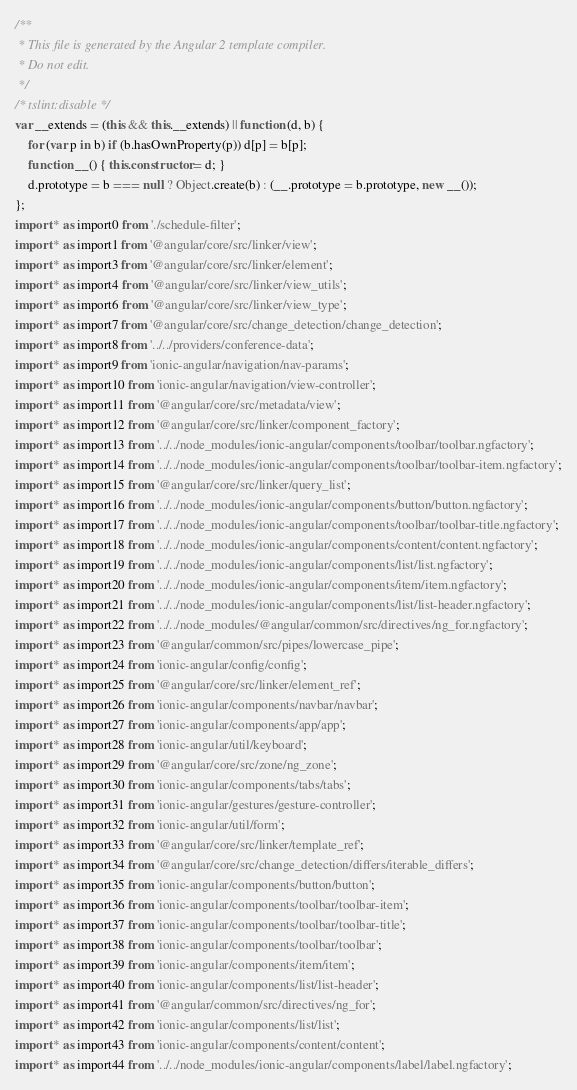<code> <loc_0><loc_0><loc_500><loc_500><_JavaScript_>/**
 * This file is generated by the Angular 2 template compiler.
 * Do not edit.
 */
/* tslint:disable */
var __extends = (this && this.__extends) || function (d, b) {
    for (var p in b) if (b.hasOwnProperty(p)) d[p] = b[p];
    function __() { this.constructor = d; }
    d.prototype = b === null ? Object.create(b) : (__.prototype = b.prototype, new __());
};
import * as import0 from './schedule-filter';
import * as import1 from '@angular/core/src/linker/view';
import * as import3 from '@angular/core/src/linker/element';
import * as import4 from '@angular/core/src/linker/view_utils';
import * as import6 from '@angular/core/src/linker/view_type';
import * as import7 from '@angular/core/src/change_detection/change_detection';
import * as import8 from '../../providers/conference-data';
import * as import9 from 'ionic-angular/navigation/nav-params';
import * as import10 from 'ionic-angular/navigation/view-controller';
import * as import11 from '@angular/core/src/metadata/view';
import * as import12 from '@angular/core/src/linker/component_factory';
import * as import13 from '../../node_modules/ionic-angular/components/toolbar/toolbar.ngfactory';
import * as import14 from '../../node_modules/ionic-angular/components/toolbar/toolbar-item.ngfactory';
import * as import15 from '@angular/core/src/linker/query_list';
import * as import16 from '../../node_modules/ionic-angular/components/button/button.ngfactory';
import * as import17 from '../../node_modules/ionic-angular/components/toolbar/toolbar-title.ngfactory';
import * as import18 from '../../node_modules/ionic-angular/components/content/content.ngfactory';
import * as import19 from '../../node_modules/ionic-angular/components/list/list.ngfactory';
import * as import20 from '../../node_modules/ionic-angular/components/item/item.ngfactory';
import * as import21 from '../../node_modules/ionic-angular/components/list/list-header.ngfactory';
import * as import22 from '../../node_modules/@angular/common/src/directives/ng_for.ngfactory';
import * as import23 from '@angular/common/src/pipes/lowercase_pipe';
import * as import24 from 'ionic-angular/config/config';
import * as import25 from '@angular/core/src/linker/element_ref';
import * as import26 from 'ionic-angular/components/navbar/navbar';
import * as import27 from 'ionic-angular/components/app/app';
import * as import28 from 'ionic-angular/util/keyboard';
import * as import29 from '@angular/core/src/zone/ng_zone';
import * as import30 from 'ionic-angular/components/tabs/tabs';
import * as import31 from 'ionic-angular/gestures/gesture-controller';
import * as import32 from 'ionic-angular/util/form';
import * as import33 from '@angular/core/src/linker/template_ref';
import * as import34 from '@angular/core/src/change_detection/differs/iterable_differs';
import * as import35 from 'ionic-angular/components/button/button';
import * as import36 from 'ionic-angular/components/toolbar/toolbar-item';
import * as import37 from 'ionic-angular/components/toolbar/toolbar-title';
import * as import38 from 'ionic-angular/components/toolbar/toolbar';
import * as import39 from 'ionic-angular/components/item/item';
import * as import40 from 'ionic-angular/components/list/list-header';
import * as import41 from '@angular/common/src/directives/ng_for';
import * as import42 from 'ionic-angular/components/list/list';
import * as import43 from 'ionic-angular/components/content/content';
import * as import44 from '../../node_modules/ionic-angular/components/label/label.ngfactory';</code> 